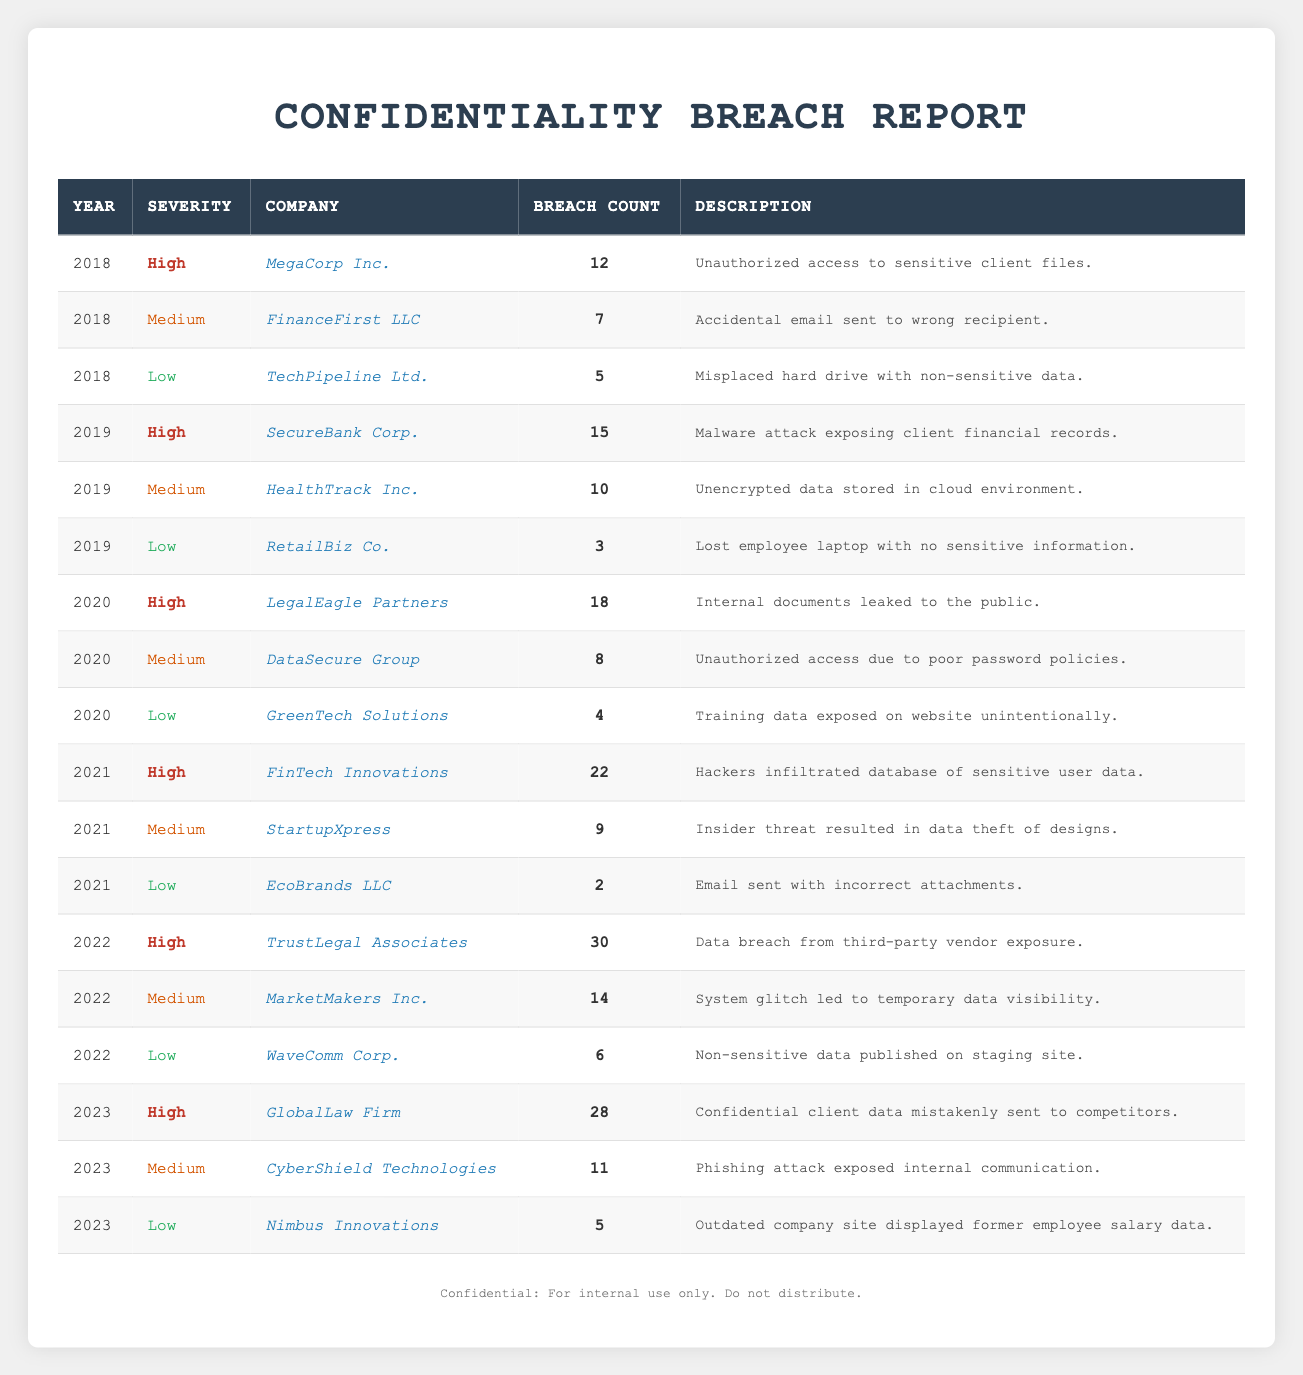What was the total number of high severity breaches in 2020? In 2020, there was one high severity breach reported, which was from LegalEagle Partners with a breach count of 18. Therefore, the total number of high severity breaches in 2020 is 18.
Answer: 18 Which company had the highest number of medium severity breaches in 2022? In 2022, MarketMakers Inc. had the highest number of medium severity breaches with a total of 14 reported.
Answer: MarketMakers Inc How many low severity breaches were reported in 2019? In 2019, there was one low severity breach reported by RetailBiz Co. with a breach count of 3. Therefore, the total number of low severity breaches in 2019 is 3.
Answer: 3 What is the average breach count for high severity breaches from 2018 to 2023? The high severity breaches are: 12 (2018) + 15 (2019) + 18 (2020) + 22 (2021) + 30 (2022) + 28 (2023) = 125. Dividing by the number of years (6) gives an average of 20.83.
Answer: 20.83 Did any company report a low severity breach in 2021? Yes, EcoBrands LLC reported a low severity breach in 2021 with a breach count of 2.
Answer: Yes What was the trend in the number of high severity breaches from 2018 to 2023? The trend shows an increase: 12 (2018), 15 (2019), 18 (2020), 22 (2021), 30 (2022), and 28 (2023), indicating a general upward trend in high severity breaches over these years.
Answer: Increasing Which year had the greatest total number of confidentiality breaches across all severity levels? By summing up all breaches: 12 + 7 + 5 + 15 + 10 + 3 + 18 + 8 + 4 + 22 + 9 + 2 + 30 + 14 + 6 + 28 + 11 + 5 =  258. The year 2022 had the greatest total with 50 breaches reported (30 high + 14 medium + 6 low).
Answer: 2022 How many companies reported low severity breaches in 2023? In 2023, only one company reported a low severity breach, which was Nimbus Innovations with a breach count of 5.
Answer: 1 What was the total number of breaches reported across all severity levels in 2021? In 2021, the total number of breaches is 22 (high) + 9 (medium) + 2 (low) = 33. Therefore, the total number of breaches reported in 2021 is 33.
Answer: 33 Which company experienced the highest number of breaches in any severity level in 2022? TrustLegal Associates experienced the highest number of breaches in 2022 with a total of 30 breaches classified as high severity.
Answer: TrustLegal Associates 